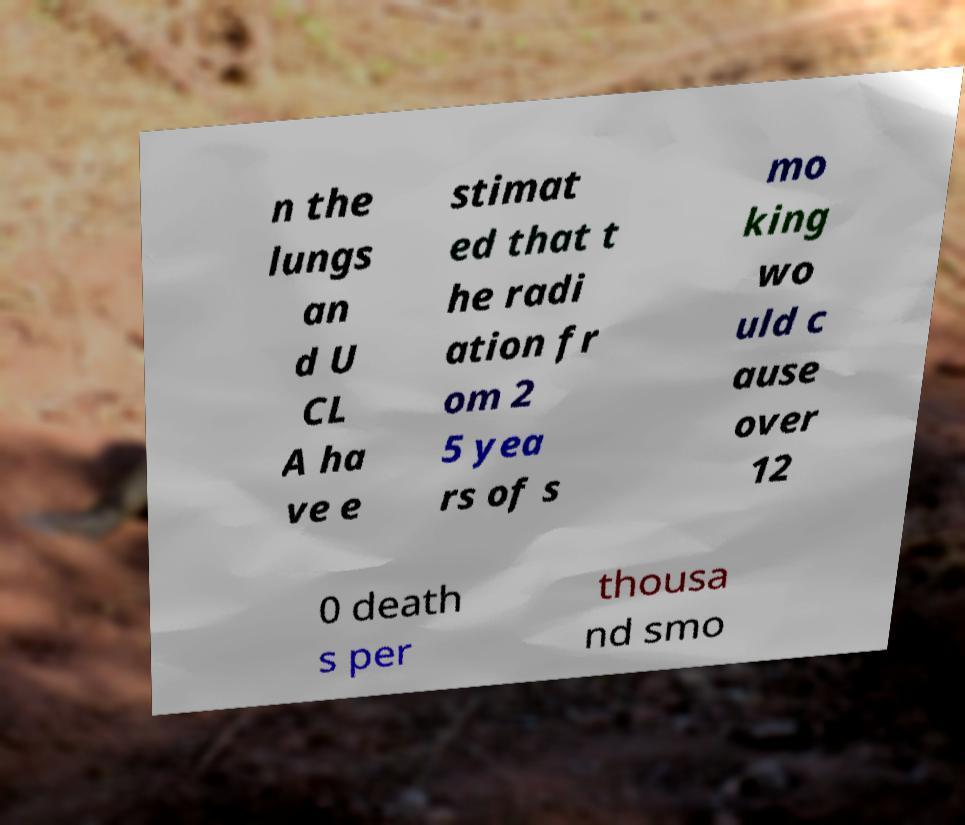Please read and relay the text visible in this image. What does it say? n the lungs an d U CL A ha ve e stimat ed that t he radi ation fr om 2 5 yea rs of s mo king wo uld c ause over 12 0 death s per thousa nd smo 